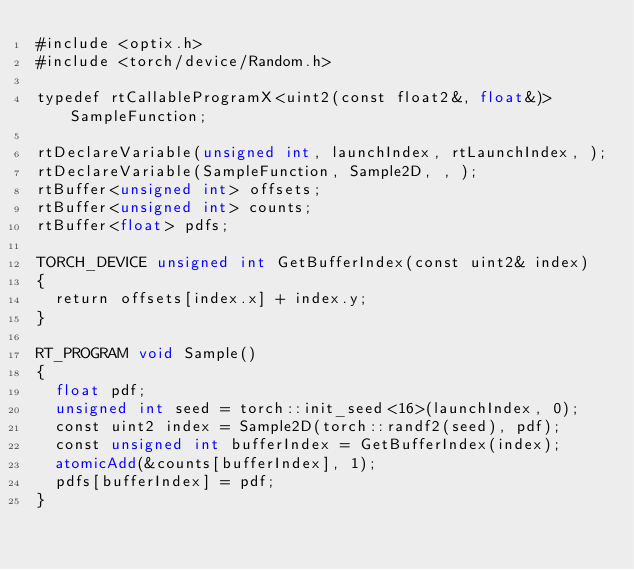Convert code to text. <code><loc_0><loc_0><loc_500><loc_500><_Cuda_>#include <optix.h>
#include <torch/device/Random.h>

typedef rtCallableProgramX<uint2(const float2&, float&)> SampleFunction;

rtDeclareVariable(unsigned int, launchIndex, rtLaunchIndex, );
rtDeclareVariable(SampleFunction, Sample2D, , );
rtBuffer<unsigned int> offsets;
rtBuffer<unsigned int> counts;
rtBuffer<float> pdfs;

TORCH_DEVICE unsigned int GetBufferIndex(const uint2& index)
{
  return offsets[index.x] + index.y;
}

RT_PROGRAM void Sample()
{
  float pdf;
  unsigned int seed = torch::init_seed<16>(launchIndex, 0);
  const uint2 index = Sample2D(torch::randf2(seed), pdf);
  const unsigned int bufferIndex = GetBufferIndex(index);
  atomicAdd(&counts[bufferIndex], 1);
  pdfs[bufferIndex] = pdf;
}</code> 